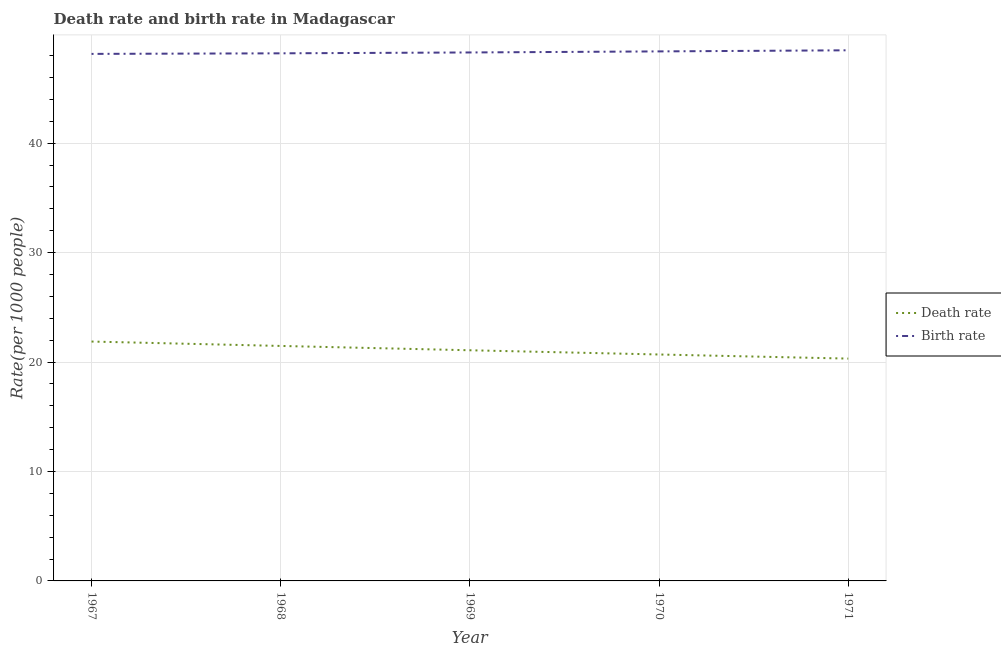Does the line corresponding to death rate intersect with the line corresponding to birth rate?
Ensure brevity in your answer.  No. Is the number of lines equal to the number of legend labels?
Offer a very short reply. Yes. What is the birth rate in 1970?
Keep it short and to the point. 48.38. Across all years, what is the maximum death rate?
Give a very brief answer. 21.87. Across all years, what is the minimum death rate?
Provide a succinct answer. 20.32. In which year was the birth rate maximum?
Offer a terse response. 1971. In which year was the death rate minimum?
Give a very brief answer. 1971. What is the total birth rate in the graph?
Offer a terse response. 241.52. What is the difference between the birth rate in 1969 and that in 1970?
Give a very brief answer. -0.1. What is the difference between the birth rate in 1971 and the death rate in 1967?
Ensure brevity in your answer.  26.61. What is the average birth rate per year?
Ensure brevity in your answer.  48.3. In the year 1968, what is the difference between the death rate and birth rate?
Your answer should be compact. -26.74. What is the ratio of the birth rate in 1970 to that in 1971?
Make the answer very short. 1. What is the difference between the highest and the second highest death rate?
Your response must be concise. 0.4. What is the difference between the highest and the lowest death rate?
Offer a very short reply. 1.56. In how many years, is the birth rate greater than the average birth rate taken over all years?
Your response must be concise. 2. Does the birth rate monotonically increase over the years?
Offer a terse response. Yes. Is the death rate strictly greater than the birth rate over the years?
Ensure brevity in your answer.  No. How many lines are there?
Provide a short and direct response. 2. What is the difference between two consecutive major ticks on the Y-axis?
Your answer should be very brief. 10. Does the graph contain any zero values?
Offer a terse response. No. How are the legend labels stacked?
Keep it short and to the point. Vertical. What is the title of the graph?
Offer a very short reply. Death rate and birth rate in Madagascar. Does "Arms imports" appear as one of the legend labels in the graph?
Make the answer very short. No. What is the label or title of the Y-axis?
Offer a terse response. Rate(per 1000 people). What is the Rate(per 1000 people) of Death rate in 1967?
Ensure brevity in your answer.  21.87. What is the Rate(per 1000 people) of Birth rate in 1967?
Give a very brief answer. 48.16. What is the Rate(per 1000 people) in Death rate in 1968?
Provide a short and direct response. 21.47. What is the Rate(per 1000 people) of Birth rate in 1968?
Make the answer very short. 48.21. What is the Rate(per 1000 people) of Death rate in 1969?
Your response must be concise. 21.08. What is the Rate(per 1000 people) in Birth rate in 1969?
Give a very brief answer. 48.29. What is the Rate(per 1000 people) in Death rate in 1970?
Offer a very short reply. 20.69. What is the Rate(per 1000 people) of Birth rate in 1970?
Provide a short and direct response. 48.38. What is the Rate(per 1000 people) of Death rate in 1971?
Make the answer very short. 20.32. What is the Rate(per 1000 people) in Birth rate in 1971?
Your answer should be very brief. 48.49. Across all years, what is the maximum Rate(per 1000 people) of Death rate?
Provide a short and direct response. 21.87. Across all years, what is the maximum Rate(per 1000 people) in Birth rate?
Your answer should be very brief. 48.49. Across all years, what is the minimum Rate(per 1000 people) in Death rate?
Your answer should be compact. 20.32. Across all years, what is the minimum Rate(per 1000 people) in Birth rate?
Provide a succinct answer. 48.16. What is the total Rate(per 1000 people) of Death rate in the graph?
Make the answer very short. 105.42. What is the total Rate(per 1000 people) of Birth rate in the graph?
Your answer should be compact. 241.53. What is the difference between the Rate(per 1000 people) in Death rate in 1967 and that in 1968?
Your response must be concise. 0.4. What is the difference between the Rate(per 1000 people) of Birth rate in 1967 and that in 1968?
Provide a short and direct response. -0.05. What is the difference between the Rate(per 1000 people) in Death rate in 1967 and that in 1969?
Offer a very short reply. 0.8. What is the difference between the Rate(per 1000 people) in Birth rate in 1967 and that in 1969?
Your response must be concise. -0.13. What is the difference between the Rate(per 1000 people) in Death rate in 1967 and that in 1970?
Your answer should be compact. 1.18. What is the difference between the Rate(per 1000 people) of Birth rate in 1967 and that in 1970?
Make the answer very short. -0.23. What is the difference between the Rate(per 1000 people) of Death rate in 1967 and that in 1971?
Give a very brief answer. 1.56. What is the difference between the Rate(per 1000 people) in Birth rate in 1967 and that in 1971?
Offer a very short reply. -0.33. What is the difference between the Rate(per 1000 people) of Death rate in 1968 and that in 1969?
Provide a short and direct response. 0.4. What is the difference between the Rate(per 1000 people) in Birth rate in 1968 and that in 1969?
Provide a succinct answer. -0.08. What is the difference between the Rate(per 1000 people) of Death rate in 1968 and that in 1970?
Your answer should be compact. 0.78. What is the difference between the Rate(per 1000 people) in Birth rate in 1968 and that in 1970?
Keep it short and to the point. -0.18. What is the difference between the Rate(per 1000 people) in Death rate in 1968 and that in 1971?
Ensure brevity in your answer.  1.16. What is the difference between the Rate(per 1000 people) in Birth rate in 1968 and that in 1971?
Provide a short and direct response. -0.28. What is the difference between the Rate(per 1000 people) in Death rate in 1969 and that in 1970?
Ensure brevity in your answer.  0.39. What is the difference between the Rate(per 1000 people) in Birth rate in 1969 and that in 1970?
Offer a terse response. -0.1. What is the difference between the Rate(per 1000 people) in Death rate in 1969 and that in 1971?
Offer a very short reply. 0.76. What is the difference between the Rate(per 1000 people) of Birth rate in 1969 and that in 1971?
Your answer should be very brief. -0.2. What is the difference between the Rate(per 1000 people) in Death rate in 1970 and that in 1971?
Make the answer very short. 0.38. What is the difference between the Rate(per 1000 people) in Birth rate in 1970 and that in 1971?
Give a very brief answer. -0.1. What is the difference between the Rate(per 1000 people) of Death rate in 1967 and the Rate(per 1000 people) of Birth rate in 1968?
Ensure brevity in your answer.  -26.34. What is the difference between the Rate(per 1000 people) of Death rate in 1967 and the Rate(per 1000 people) of Birth rate in 1969?
Your response must be concise. -26.41. What is the difference between the Rate(per 1000 people) of Death rate in 1967 and the Rate(per 1000 people) of Birth rate in 1970?
Provide a short and direct response. -26.51. What is the difference between the Rate(per 1000 people) in Death rate in 1967 and the Rate(per 1000 people) in Birth rate in 1971?
Your answer should be very brief. -26.61. What is the difference between the Rate(per 1000 people) in Death rate in 1968 and the Rate(per 1000 people) in Birth rate in 1969?
Make the answer very short. -26.82. What is the difference between the Rate(per 1000 people) of Death rate in 1968 and the Rate(per 1000 people) of Birth rate in 1970?
Keep it short and to the point. -26.91. What is the difference between the Rate(per 1000 people) of Death rate in 1968 and the Rate(per 1000 people) of Birth rate in 1971?
Provide a succinct answer. -27.02. What is the difference between the Rate(per 1000 people) in Death rate in 1969 and the Rate(per 1000 people) in Birth rate in 1970?
Offer a terse response. -27.31. What is the difference between the Rate(per 1000 people) in Death rate in 1969 and the Rate(per 1000 people) in Birth rate in 1971?
Keep it short and to the point. -27.41. What is the difference between the Rate(per 1000 people) in Death rate in 1970 and the Rate(per 1000 people) in Birth rate in 1971?
Offer a very short reply. -27.8. What is the average Rate(per 1000 people) in Death rate per year?
Offer a terse response. 21.09. What is the average Rate(per 1000 people) in Birth rate per year?
Keep it short and to the point. 48.3. In the year 1967, what is the difference between the Rate(per 1000 people) in Death rate and Rate(per 1000 people) in Birth rate?
Your answer should be compact. -26.28. In the year 1968, what is the difference between the Rate(per 1000 people) in Death rate and Rate(per 1000 people) in Birth rate?
Provide a succinct answer. -26.74. In the year 1969, what is the difference between the Rate(per 1000 people) of Death rate and Rate(per 1000 people) of Birth rate?
Your answer should be very brief. -27.21. In the year 1970, what is the difference between the Rate(per 1000 people) of Death rate and Rate(per 1000 people) of Birth rate?
Your response must be concise. -27.7. In the year 1971, what is the difference between the Rate(per 1000 people) of Death rate and Rate(per 1000 people) of Birth rate?
Offer a terse response. -28.17. What is the ratio of the Rate(per 1000 people) in Death rate in 1967 to that in 1968?
Your response must be concise. 1.02. What is the ratio of the Rate(per 1000 people) of Birth rate in 1967 to that in 1968?
Keep it short and to the point. 1. What is the ratio of the Rate(per 1000 people) in Death rate in 1967 to that in 1969?
Make the answer very short. 1.04. What is the ratio of the Rate(per 1000 people) in Death rate in 1967 to that in 1970?
Ensure brevity in your answer.  1.06. What is the ratio of the Rate(per 1000 people) of Death rate in 1967 to that in 1971?
Your response must be concise. 1.08. What is the ratio of the Rate(per 1000 people) in Death rate in 1968 to that in 1969?
Your answer should be very brief. 1.02. What is the ratio of the Rate(per 1000 people) of Birth rate in 1968 to that in 1969?
Provide a short and direct response. 1. What is the ratio of the Rate(per 1000 people) of Death rate in 1968 to that in 1970?
Offer a very short reply. 1.04. What is the ratio of the Rate(per 1000 people) of Death rate in 1968 to that in 1971?
Provide a short and direct response. 1.06. What is the ratio of the Rate(per 1000 people) in Death rate in 1969 to that in 1970?
Your answer should be very brief. 1.02. What is the ratio of the Rate(per 1000 people) of Birth rate in 1969 to that in 1970?
Your answer should be compact. 1. What is the ratio of the Rate(per 1000 people) in Death rate in 1969 to that in 1971?
Keep it short and to the point. 1.04. What is the ratio of the Rate(per 1000 people) of Death rate in 1970 to that in 1971?
Your response must be concise. 1.02. What is the difference between the highest and the second highest Rate(per 1000 people) of Death rate?
Keep it short and to the point. 0.4. What is the difference between the highest and the second highest Rate(per 1000 people) in Birth rate?
Provide a short and direct response. 0.1. What is the difference between the highest and the lowest Rate(per 1000 people) in Death rate?
Give a very brief answer. 1.56. What is the difference between the highest and the lowest Rate(per 1000 people) of Birth rate?
Offer a very short reply. 0.33. 